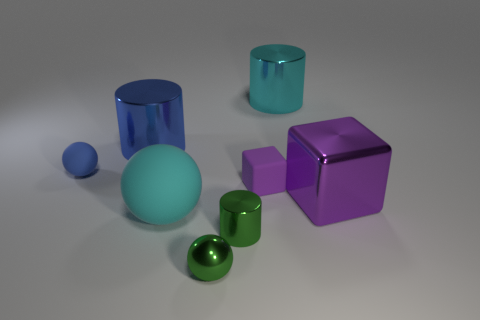Add 1 gray metallic objects. How many objects exist? 9 Subtract all tiny green balls. How many balls are left? 2 Add 7 blue metal cylinders. How many blue metal cylinders are left? 8 Add 3 small blue rubber blocks. How many small blue rubber blocks exist? 3 Subtract 0 brown blocks. How many objects are left? 8 Subtract all balls. How many objects are left? 5 Subtract 2 spheres. How many spheres are left? 1 Subtract all yellow spheres. Subtract all green cylinders. How many spheres are left? 3 Subtract all yellow balls. How many yellow cylinders are left? 0 Subtract all tiny spheres. Subtract all purple objects. How many objects are left? 4 